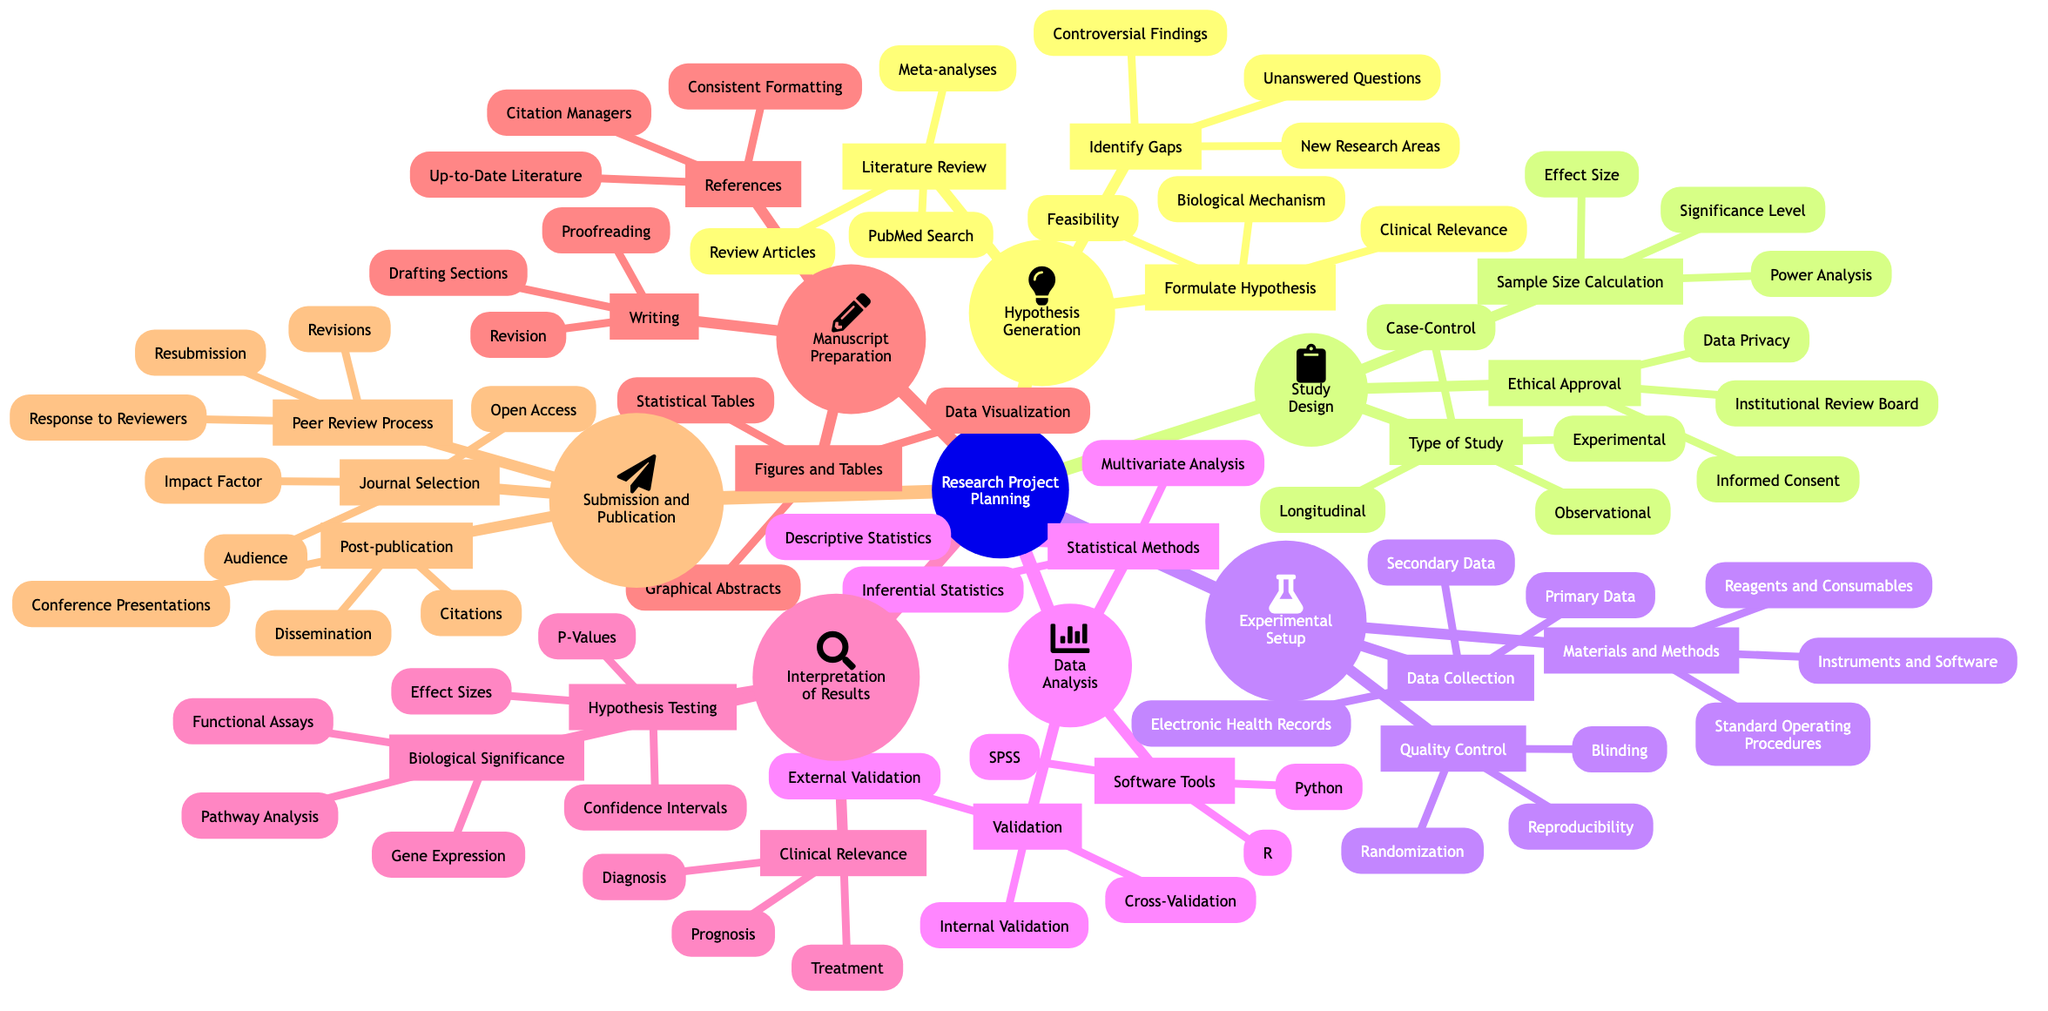What are the three main components of "Hypothesis Generation"? The main components are Literature Review, Identify Gaps, and Formulate Hypothesis, which are found in the first branch of the mind map under "Hypothesis Generation".
Answer: Literature Review, Identify Gaps, Formulate Hypothesis How many types of studies are listed under "Study Design"? Under "Study Design", there are four types listed: Experimental, Observational, Longitudinal, and Case-Control. This can be counted directly from the diagram.
Answer: Four Which statistical method is categorized under "Data Analysis"? The listed statistical methods under "Data Analysis" are Descriptive Statistics, Inferential Statistics, and Multivariate Analysis, directly visible in the corresponding node.
Answer: Descriptive Statistics, Inferential Statistics, Multivariate Analysis What is one requirement for "Ethical Approval"? A requirement for "Ethical Approval" is Institutional Review Board, which appears as one of the options in the "Ethical Approval" node under "Study Design".
Answer: Institutional Review Board What is the relationship between "Biological Significance" and "Clinical Relevance"? "Biological Significance" and "Clinical Relevance" are both components found under "Interpretation of Results", suggesting they are parallel categories aimed at interpreting outcomes of research, rather than being directly related to one another.
Answer: Parallel categories What are the two main activities listed under "Manuscript Preparation"? The two main activities are Writing and Figures and Tables, which are primary branches of the "Manuscript Preparation" section of the mind map.
Answer: Writing, Figures and Tables How many nodes are present in the "Submission and Publication" section? In the "Submission and Publication" section, there are three nodes: Journal Selection, Peer Review Process, and Post-publication, which can be counted from the diagram.
Answer: Three Explain the process involved in the peer review phase. The peer review phase involves "Response to Reviewers", "Revisions", and "Resubmission". This indicates a structured process where the manuscript is reviewed, feedback is addressed through revisions, and then resubmitted for further consideration by the journal.
Answer: Response to Reviewers, Revisions, Resubmission Which phase follows "Data Analysis"? The phase that follows "Data Analysis" in the mind map is "Interpretation of Results", indicating that after analyzing the data, one interprets the findings.
Answer: Interpretation of Results 